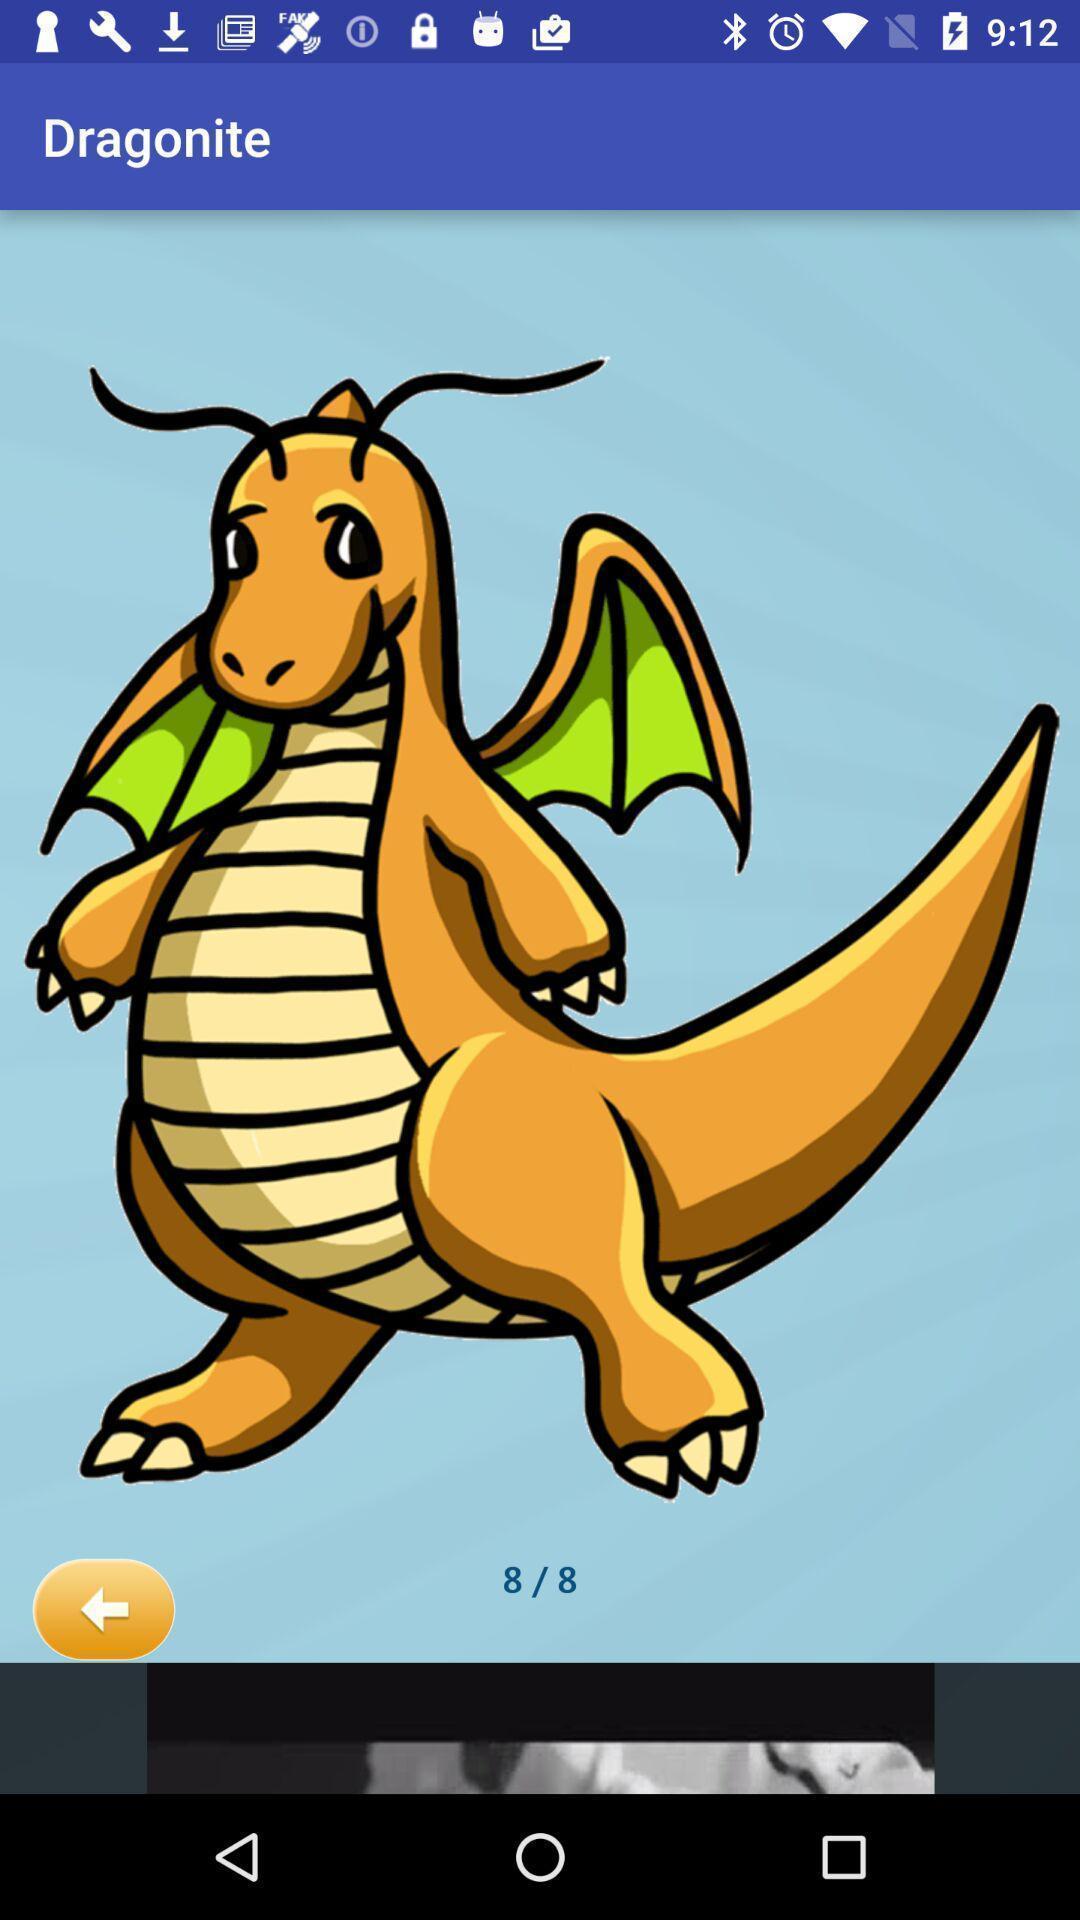Explain the elements present in this screenshot. Screen displaying the dragon image. 